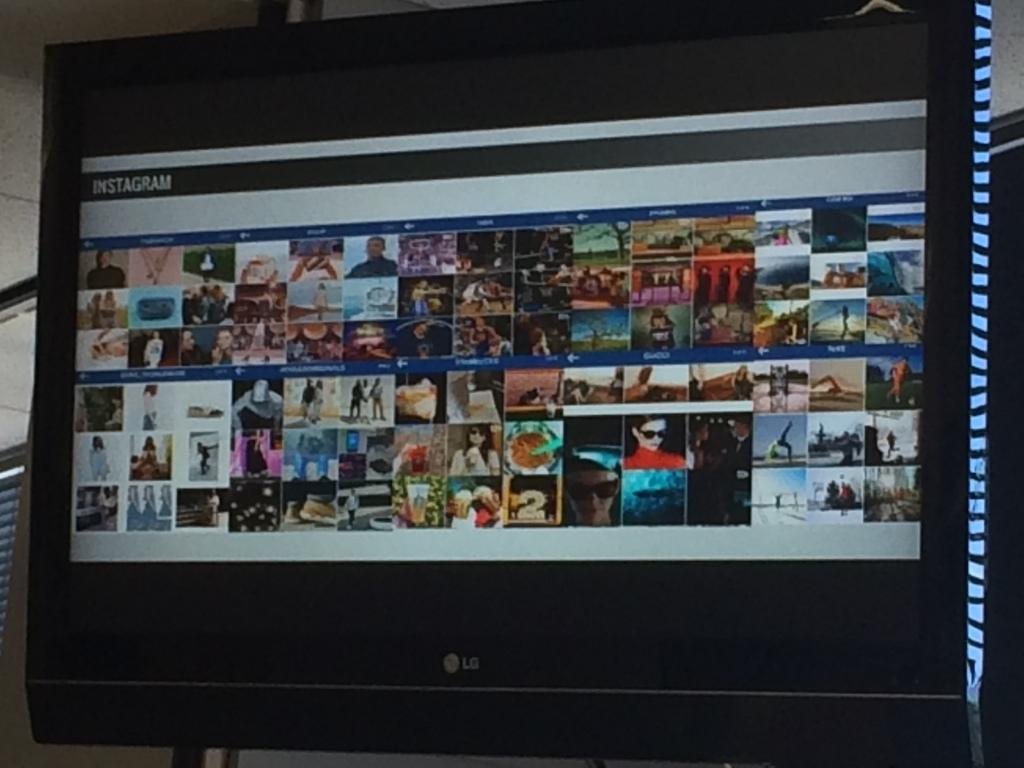<image>
Give a short and clear explanation of the subsequent image. A LG computer monitor displaying a variety of thumbnails. 